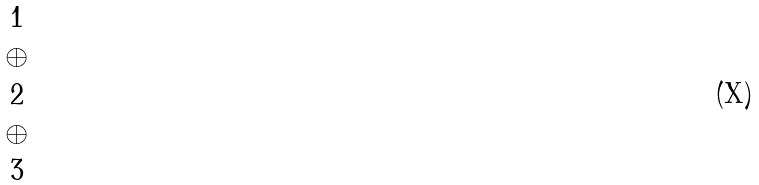<formula> <loc_0><loc_0><loc_500><loc_500>\begin{matrix} 1 \\ \oplus \\ 2 \\ \oplus \\ 3 \end{matrix}</formula> 